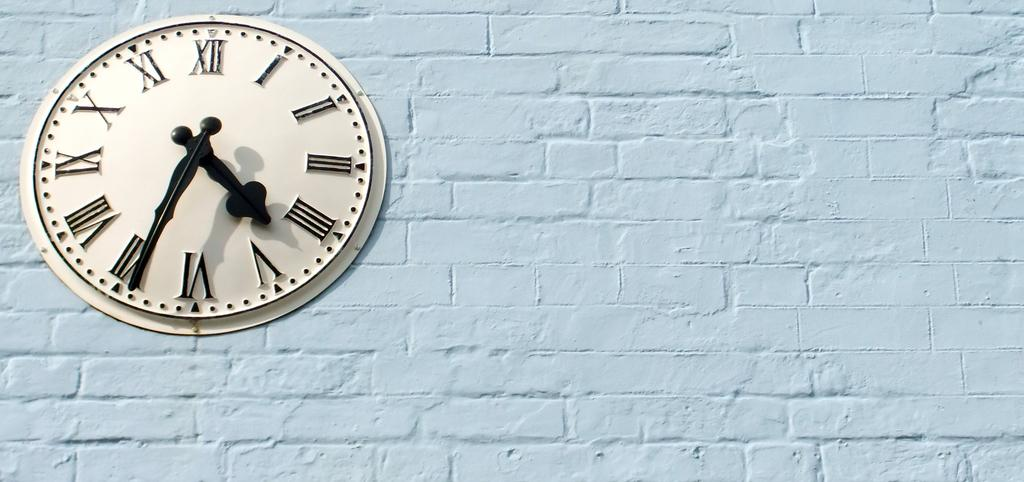What object is attached to the wall in the image? There is a clock in the image, and it is attached to the wall. What type of numbers are displayed on the clock? The clock has roman numbers. How many hands are on the clock? There is a short hand and a long hand on the clock. What color is the lead used to write on the chalkboard in the image? There is no chalkboard or lead present in the image; it features a clock attached to the wall with roman numbers and two hands. 